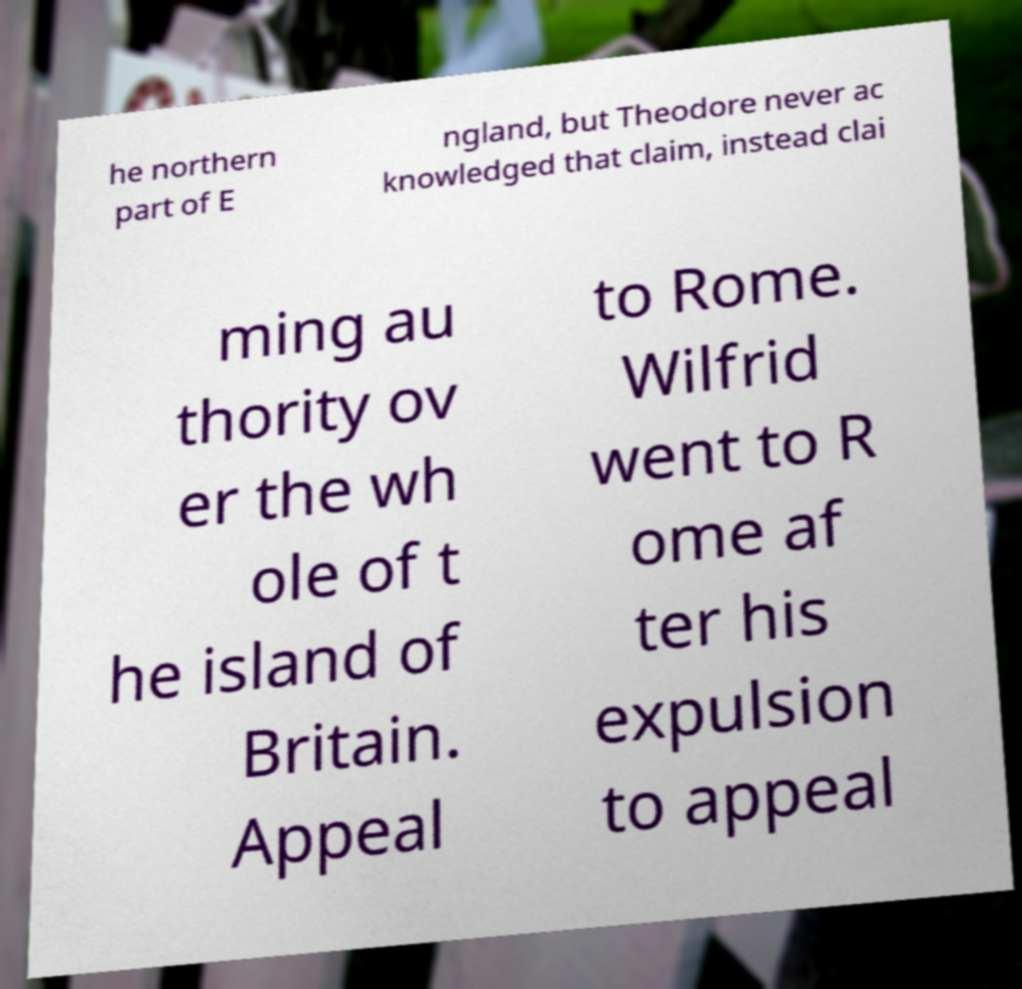Please read and relay the text visible in this image. What does it say? he northern part of E ngland, but Theodore never ac knowledged that claim, instead clai ming au thority ov er the wh ole of t he island of Britain. Appeal to Rome. Wilfrid went to R ome af ter his expulsion to appeal 